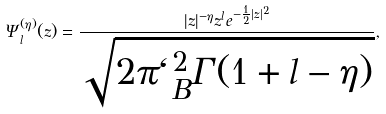Convert formula to latex. <formula><loc_0><loc_0><loc_500><loc_500>\Psi _ { l } ^ { ( \eta ) } ( z ) = \frac { | z | ^ { - \eta } z ^ { l } e ^ { - \frac { 1 } { 2 } { | z | ^ { 2 } } } } { \sqrt { 2 \pi \ell _ { B } ^ { 2 } \Gamma ( 1 + l - \eta ) } } ,</formula> 